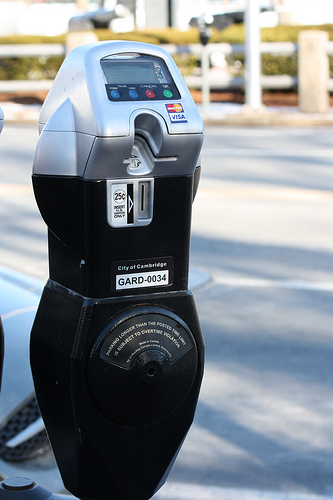Please provide a short description for this region: [0.39, 0.18, 0.44, 0.2]. This region depicts a series of blue operational buttons on the meter. They are presumably for selecting parking time, initiating transactions, or canceling operations. 